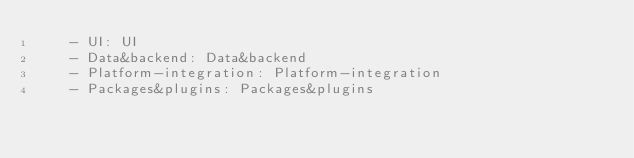<code> <loc_0><loc_0><loc_500><loc_500><_YAML_>    - UI: UI
    - Data&backend: Data&backend
    - Platform-integration: Platform-integration
    - Packages&plugins: Packages&plugins
    
    </code> 